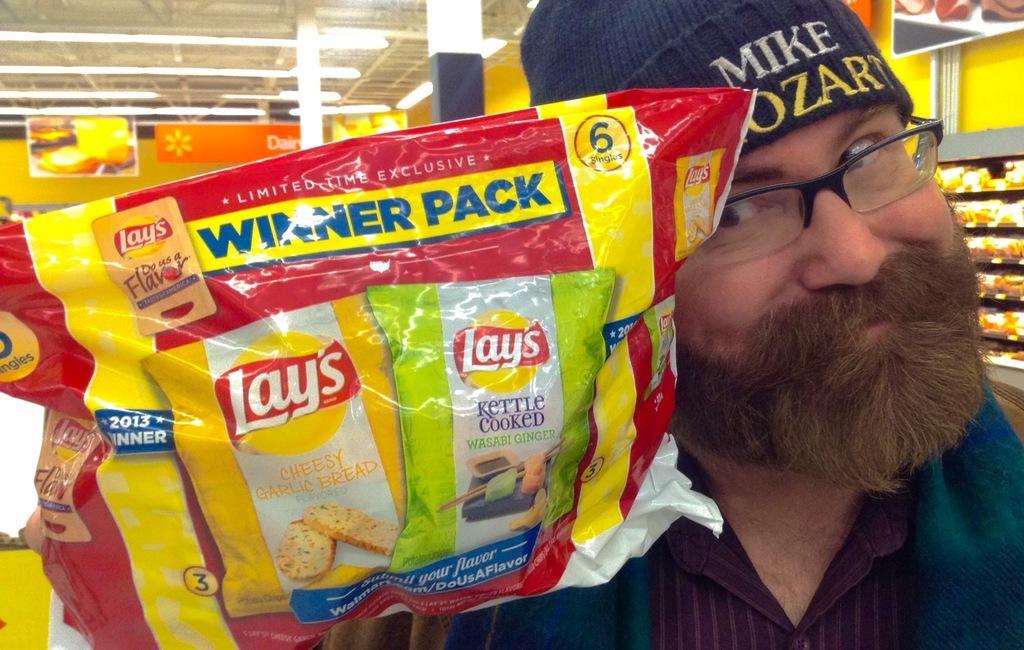How would you summarize this image in a sentence or two? In this image I can see a packet on the left side and on it I can see something is written. On the right side of this image I can see a man and I can see he is wearing a cap, specs and shirt. On the top left side of this image I can see number of lights and few boards. 